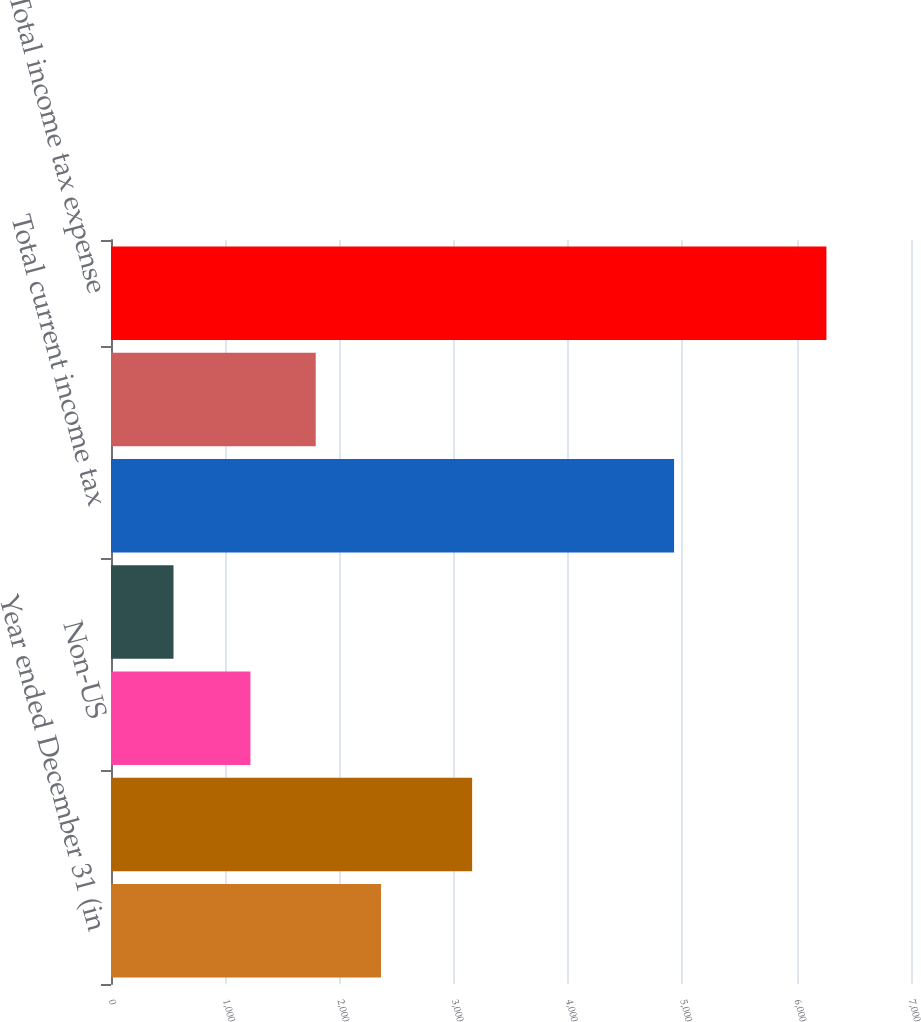<chart> <loc_0><loc_0><loc_500><loc_500><bar_chart><fcel>Year ended December 31 (in<fcel>US federal<fcel>Non-US<fcel>US state and local<fcel>Total current income tax<fcel>Total deferred income tax<fcel>Total income tax expense<nl><fcel>2362.6<fcel>3160<fcel>1220<fcel>547<fcel>4927<fcel>1791.3<fcel>6260<nl></chart> 